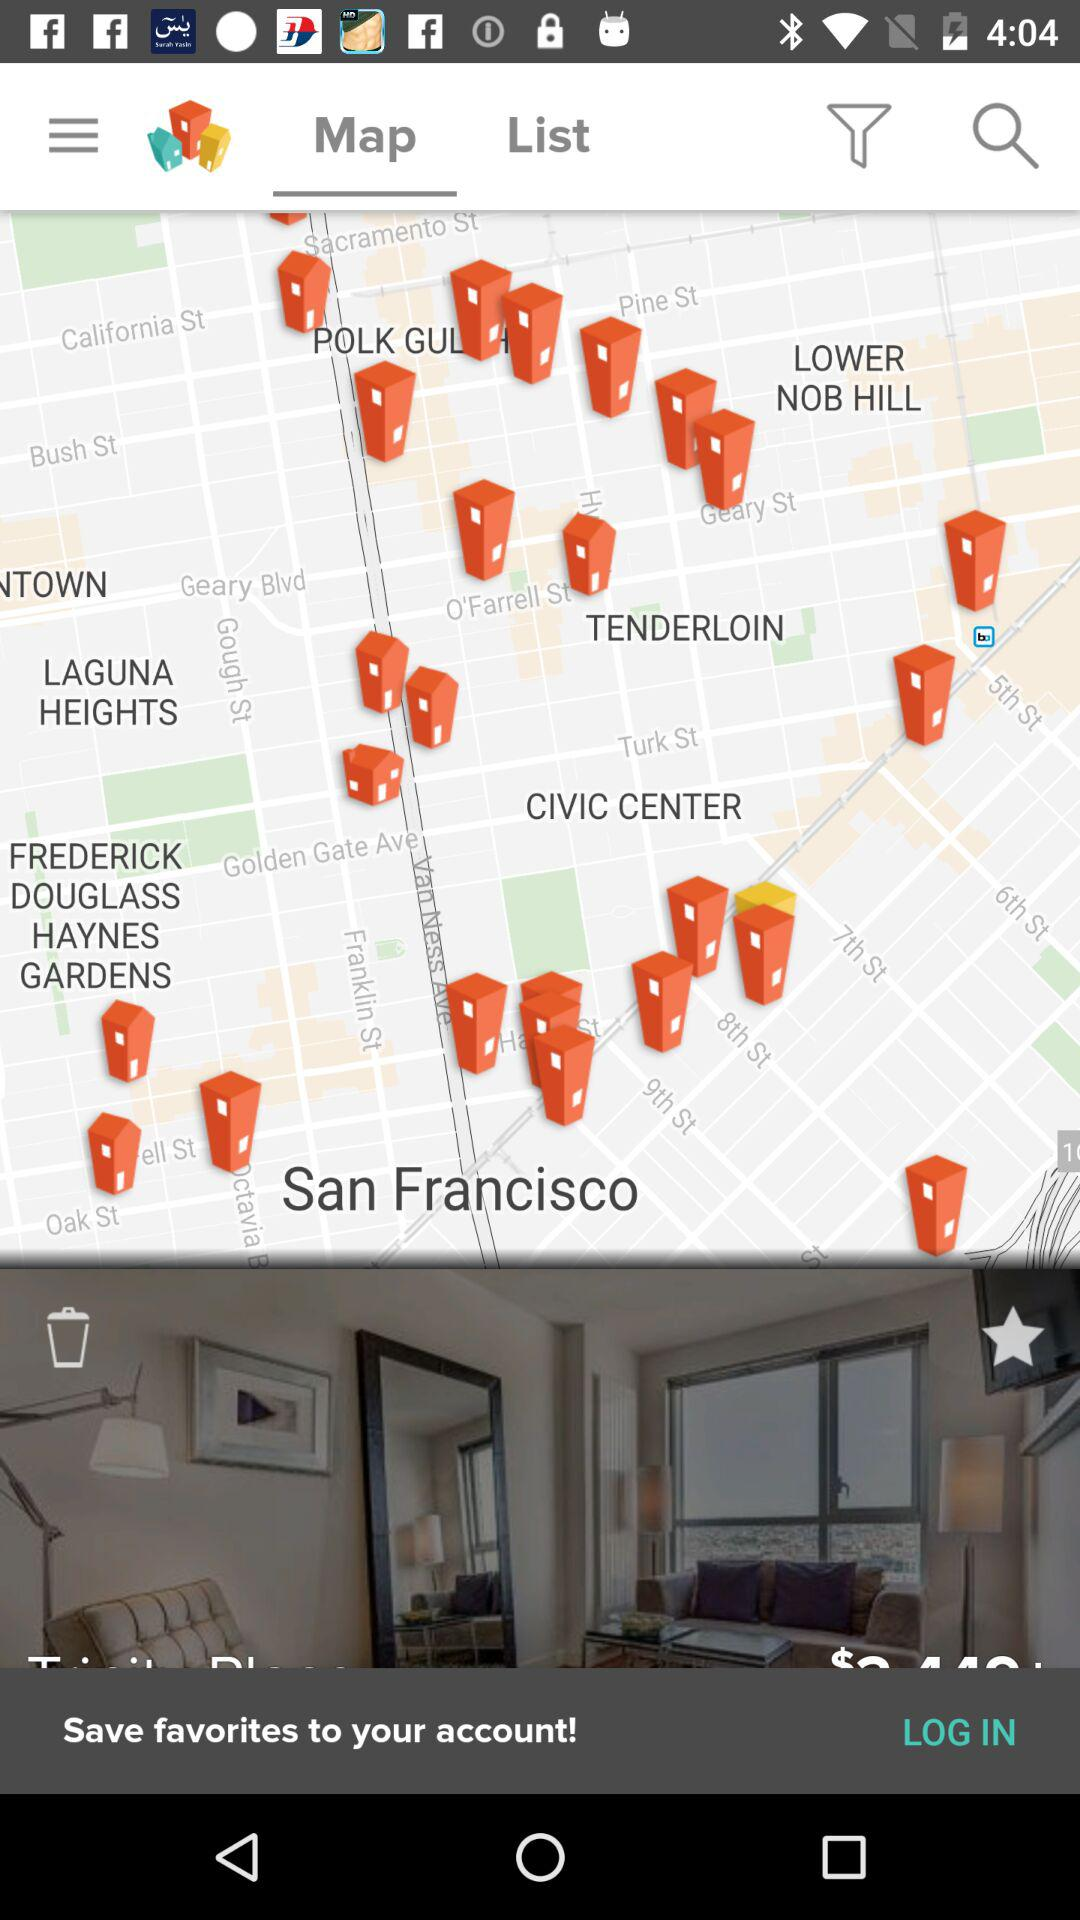What city is shown on the map? The city shown on the map is San Francisco. 